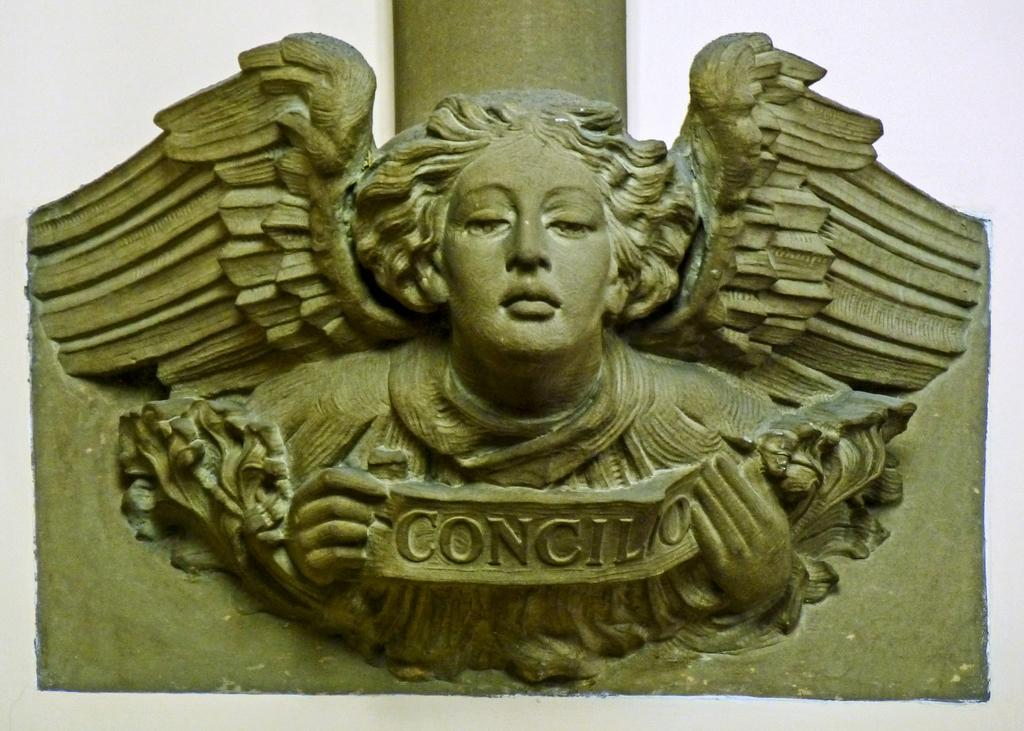What is the main subject of the image? The main subject of the image is a stone carving. What can be seen on the stone carving? There is text visible on the stone carving. What type of lace can be seen on the stone carving in the image? There is no lace present on the stone carving in the image. Can you tell me how many times the stone carving was kicked before the text was added? There is no information about the stone carving being kicked in the image or the provided facts. 